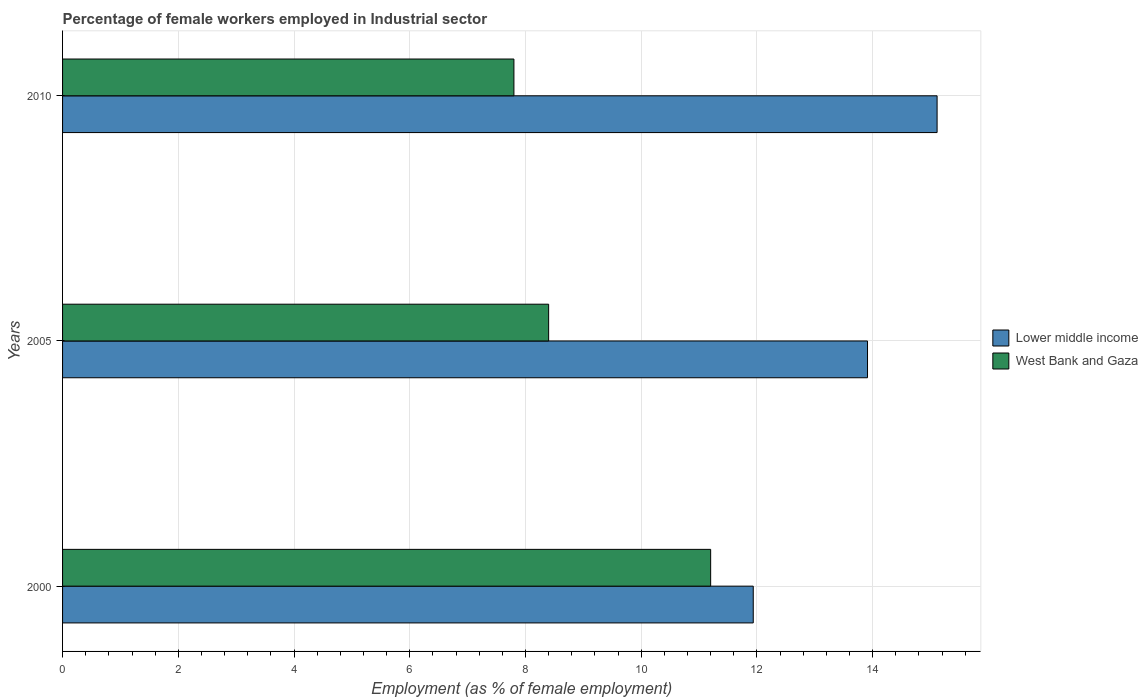How many different coloured bars are there?
Provide a short and direct response. 2. Are the number of bars per tick equal to the number of legend labels?
Offer a terse response. Yes. How many bars are there on the 3rd tick from the bottom?
Keep it short and to the point. 2. What is the label of the 2nd group of bars from the top?
Your response must be concise. 2005. What is the percentage of females employed in Industrial sector in Lower middle income in 2000?
Give a very brief answer. 11.94. Across all years, what is the maximum percentage of females employed in Industrial sector in Lower middle income?
Offer a terse response. 15.11. Across all years, what is the minimum percentage of females employed in Industrial sector in Lower middle income?
Your answer should be compact. 11.94. In which year was the percentage of females employed in Industrial sector in West Bank and Gaza maximum?
Make the answer very short. 2000. What is the total percentage of females employed in Industrial sector in West Bank and Gaza in the graph?
Your response must be concise. 27.4. What is the difference between the percentage of females employed in Industrial sector in Lower middle income in 2005 and that in 2010?
Give a very brief answer. -1.2. What is the difference between the percentage of females employed in Industrial sector in West Bank and Gaza in 2010 and the percentage of females employed in Industrial sector in Lower middle income in 2000?
Offer a very short reply. -4.14. What is the average percentage of females employed in Industrial sector in West Bank and Gaza per year?
Your answer should be compact. 9.13. In the year 2005, what is the difference between the percentage of females employed in Industrial sector in West Bank and Gaza and percentage of females employed in Industrial sector in Lower middle income?
Ensure brevity in your answer.  -5.51. What is the ratio of the percentage of females employed in Industrial sector in West Bank and Gaza in 2005 to that in 2010?
Offer a very short reply. 1.08. What is the difference between the highest and the second highest percentage of females employed in Industrial sector in West Bank and Gaza?
Your answer should be compact. 2.8. What is the difference between the highest and the lowest percentage of females employed in Industrial sector in Lower middle income?
Provide a succinct answer. 3.18. Is the sum of the percentage of females employed in Industrial sector in Lower middle income in 2005 and 2010 greater than the maximum percentage of females employed in Industrial sector in West Bank and Gaza across all years?
Make the answer very short. Yes. What does the 2nd bar from the top in 2010 represents?
Keep it short and to the point. Lower middle income. What does the 2nd bar from the bottom in 2010 represents?
Make the answer very short. West Bank and Gaza. How many bars are there?
Your response must be concise. 6. Are all the bars in the graph horizontal?
Ensure brevity in your answer.  Yes. How many years are there in the graph?
Ensure brevity in your answer.  3. Are the values on the major ticks of X-axis written in scientific E-notation?
Provide a short and direct response. No. Does the graph contain any zero values?
Keep it short and to the point. No. Where does the legend appear in the graph?
Your answer should be very brief. Center right. How are the legend labels stacked?
Give a very brief answer. Vertical. What is the title of the graph?
Give a very brief answer. Percentage of female workers employed in Industrial sector. What is the label or title of the X-axis?
Make the answer very short. Employment (as % of female employment). What is the label or title of the Y-axis?
Keep it short and to the point. Years. What is the Employment (as % of female employment) of Lower middle income in 2000?
Your answer should be very brief. 11.94. What is the Employment (as % of female employment) in West Bank and Gaza in 2000?
Your response must be concise. 11.2. What is the Employment (as % of female employment) of Lower middle income in 2005?
Your response must be concise. 13.91. What is the Employment (as % of female employment) of West Bank and Gaza in 2005?
Provide a succinct answer. 8.4. What is the Employment (as % of female employment) in Lower middle income in 2010?
Provide a short and direct response. 15.11. What is the Employment (as % of female employment) in West Bank and Gaza in 2010?
Your response must be concise. 7.8. Across all years, what is the maximum Employment (as % of female employment) of Lower middle income?
Offer a terse response. 15.11. Across all years, what is the maximum Employment (as % of female employment) in West Bank and Gaza?
Your answer should be very brief. 11.2. Across all years, what is the minimum Employment (as % of female employment) of Lower middle income?
Keep it short and to the point. 11.94. Across all years, what is the minimum Employment (as % of female employment) in West Bank and Gaza?
Your response must be concise. 7.8. What is the total Employment (as % of female employment) of Lower middle income in the graph?
Give a very brief answer. 40.96. What is the total Employment (as % of female employment) of West Bank and Gaza in the graph?
Your answer should be compact. 27.4. What is the difference between the Employment (as % of female employment) of Lower middle income in 2000 and that in 2005?
Provide a short and direct response. -1.97. What is the difference between the Employment (as % of female employment) in Lower middle income in 2000 and that in 2010?
Offer a terse response. -3.18. What is the difference between the Employment (as % of female employment) of West Bank and Gaza in 2000 and that in 2010?
Ensure brevity in your answer.  3.4. What is the difference between the Employment (as % of female employment) of Lower middle income in 2005 and that in 2010?
Provide a succinct answer. -1.2. What is the difference between the Employment (as % of female employment) of West Bank and Gaza in 2005 and that in 2010?
Your response must be concise. 0.6. What is the difference between the Employment (as % of female employment) in Lower middle income in 2000 and the Employment (as % of female employment) in West Bank and Gaza in 2005?
Provide a succinct answer. 3.54. What is the difference between the Employment (as % of female employment) of Lower middle income in 2000 and the Employment (as % of female employment) of West Bank and Gaza in 2010?
Your answer should be very brief. 4.14. What is the difference between the Employment (as % of female employment) of Lower middle income in 2005 and the Employment (as % of female employment) of West Bank and Gaza in 2010?
Your answer should be compact. 6.11. What is the average Employment (as % of female employment) in Lower middle income per year?
Provide a short and direct response. 13.65. What is the average Employment (as % of female employment) in West Bank and Gaza per year?
Your response must be concise. 9.13. In the year 2000, what is the difference between the Employment (as % of female employment) of Lower middle income and Employment (as % of female employment) of West Bank and Gaza?
Give a very brief answer. 0.74. In the year 2005, what is the difference between the Employment (as % of female employment) in Lower middle income and Employment (as % of female employment) in West Bank and Gaza?
Offer a terse response. 5.51. In the year 2010, what is the difference between the Employment (as % of female employment) in Lower middle income and Employment (as % of female employment) in West Bank and Gaza?
Offer a terse response. 7.31. What is the ratio of the Employment (as % of female employment) in Lower middle income in 2000 to that in 2005?
Provide a short and direct response. 0.86. What is the ratio of the Employment (as % of female employment) of Lower middle income in 2000 to that in 2010?
Give a very brief answer. 0.79. What is the ratio of the Employment (as % of female employment) in West Bank and Gaza in 2000 to that in 2010?
Give a very brief answer. 1.44. What is the ratio of the Employment (as % of female employment) of Lower middle income in 2005 to that in 2010?
Ensure brevity in your answer.  0.92. What is the ratio of the Employment (as % of female employment) in West Bank and Gaza in 2005 to that in 2010?
Ensure brevity in your answer.  1.08. What is the difference between the highest and the second highest Employment (as % of female employment) in Lower middle income?
Offer a terse response. 1.2. What is the difference between the highest and the second highest Employment (as % of female employment) in West Bank and Gaza?
Provide a succinct answer. 2.8. What is the difference between the highest and the lowest Employment (as % of female employment) in Lower middle income?
Your answer should be very brief. 3.18. What is the difference between the highest and the lowest Employment (as % of female employment) of West Bank and Gaza?
Offer a very short reply. 3.4. 